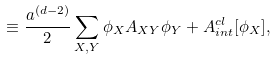Convert formula to latex. <formula><loc_0><loc_0><loc_500><loc_500>\equiv \frac { a ^ { ( d - 2 ) } } { 2 } \sum _ { X , Y } \phi _ { X } A _ { X Y } \phi _ { Y } + A ^ { c l } _ { i n t } [ \phi _ { X } ] ,</formula> 